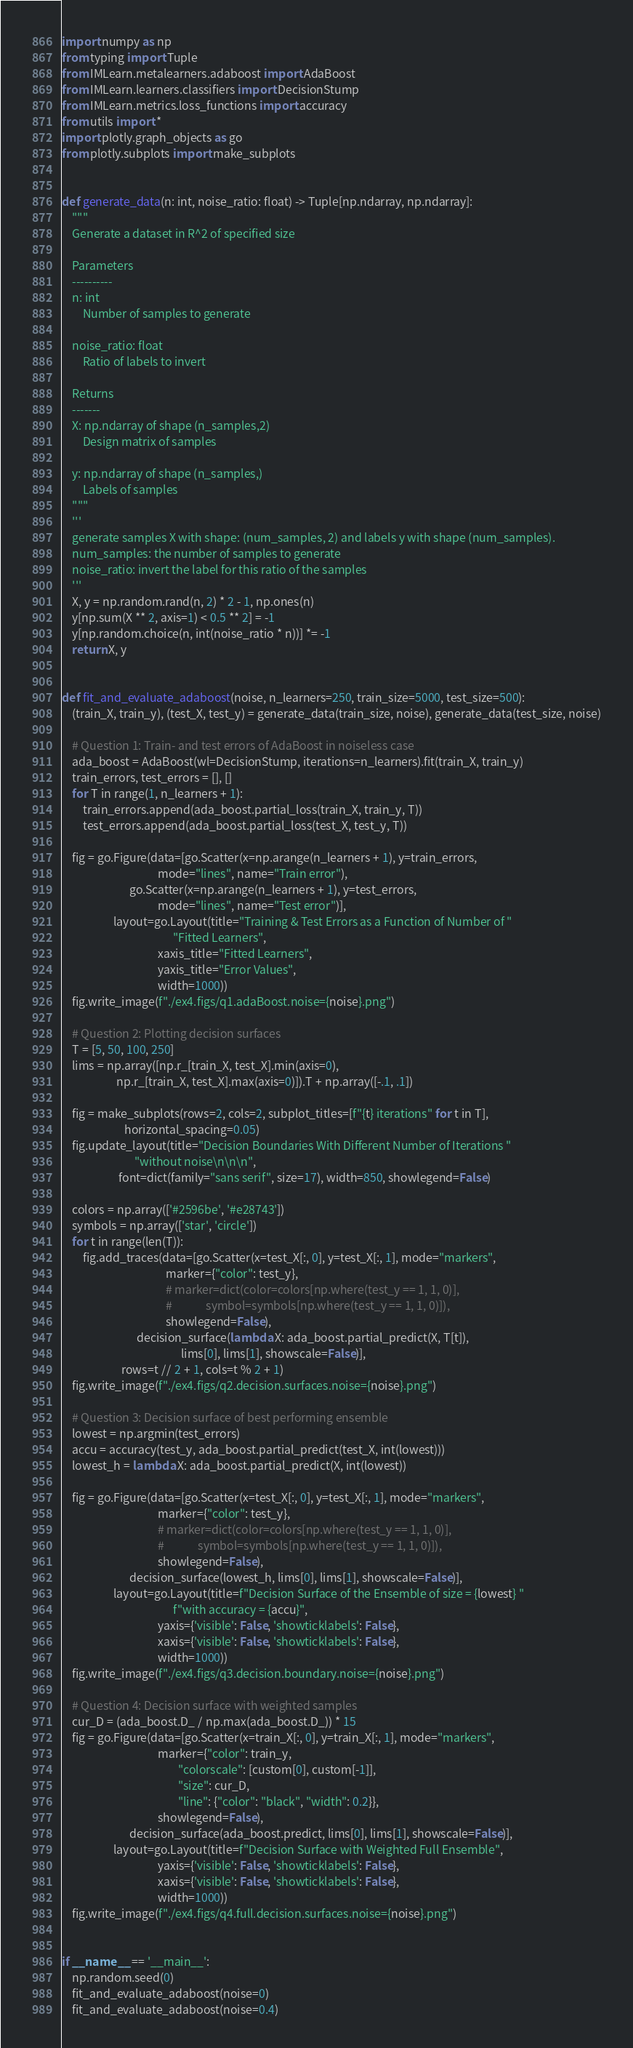<code> <loc_0><loc_0><loc_500><loc_500><_Python_>import numpy as np
from typing import Tuple
from IMLearn.metalearners.adaboost import AdaBoost
from IMLearn.learners.classifiers import DecisionStump
from IMLearn.metrics.loss_functions import accuracy
from utils import *
import plotly.graph_objects as go
from plotly.subplots import make_subplots


def generate_data(n: int, noise_ratio: float) -> Tuple[np.ndarray, np.ndarray]:
    """
    Generate a dataset in R^2 of specified size

    Parameters
    ----------
    n: int
        Number of samples to generate

    noise_ratio: float
        Ratio of labels to invert

    Returns
    -------
    X: np.ndarray of shape (n_samples,2)
        Design matrix of samples

    y: np.ndarray of shape (n_samples,)
        Labels of samples
    """
    '''
    generate samples X with shape: (num_samples, 2) and labels y with shape (num_samples).
    num_samples: the number of samples to generate
    noise_ratio: invert the label for this ratio of the samples
    '''
    X, y = np.random.rand(n, 2) * 2 - 1, np.ones(n)
    y[np.sum(X ** 2, axis=1) < 0.5 ** 2] = -1
    y[np.random.choice(n, int(noise_ratio * n))] *= -1
    return X, y


def fit_and_evaluate_adaboost(noise, n_learners=250, train_size=5000, test_size=500):
    (train_X, train_y), (test_X, test_y) = generate_data(train_size, noise), generate_data(test_size, noise)

    # Question 1: Train- and test errors of AdaBoost in noiseless case
    ada_boost = AdaBoost(wl=DecisionStump, iterations=n_learners).fit(train_X, train_y)
    train_errors, test_errors = [], []
    for T in range(1, n_learners + 1):
        train_errors.append(ada_boost.partial_loss(train_X, train_y, T))
        test_errors.append(ada_boost.partial_loss(test_X, test_y, T))

    fig = go.Figure(data=[go.Scatter(x=np.arange(n_learners + 1), y=train_errors,
                                     mode="lines", name="Train error"),
                          go.Scatter(x=np.arange(n_learners + 1), y=test_errors,
                                     mode="lines", name="Test error")],
                    layout=go.Layout(title="Training & Test Errors as a Function of Number of "
                                           "Fitted Learners",
                                     xaxis_title="Fitted Learners",
                                     yaxis_title="Error Values",
                                     width=1000))
    fig.write_image(f"./ex4.figs/q1.adaBoost.noise={noise}.png")

    # Question 2: Plotting decision surfaces
    T = [5, 50, 100, 250]
    lims = np.array([np.r_[train_X, test_X].min(axis=0),
                     np.r_[train_X, test_X].max(axis=0)]).T + np.array([-.1, .1])

    fig = make_subplots(rows=2, cols=2, subplot_titles=[f"{t} iterations" for t in T],
                        horizontal_spacing=0.05)
    fig.update_layout(title="Decision Boundaries With Different Number of Iterations "
                            "without noise\n\n\n",
                      font=dict(family="sans serif", size=17), width=850, showlegend=False)

    colors = np.array(['#2596be', '#e28743'])
    symbols = np.array(['star', 'circle'])
    for t in range(len(T)):
        fig.add_traces(data=[go.Scatter(x=test_X[:, 0], y=test_X[:, 1], mode="markers",
                                        marker={"color": test_y},
                                        # marker=dict(color=colors[np.where(test_y == 1, 1, 0)],
                                        #             symbol=symbols[np.where(test_y == 1, 1, 0)]),
                                        showlegend=False),
                             decision_surface(lambda X: ada_boost.partial_predict(X, T[t]),
                                              lims[0], lims[1], showscale=False)],
                       rows=t // 2 + 1, cols=t % 2 + 1)
    fig.write_image(f"./ex4.figs/q2.decision.surfaces.noise={noise}.png")

    # Question 3: Decision surface of best performing ensemble
    lowest = np.argmin(test_errors)
    accu = accuracy(test_y, ada_boost.partial_predict(test_X, int(lowest)))
    lowest_h = lambda X: ada_boost.partial_predict(X, int(lowest))

    fig = go.Figure(data=[go.Scatter(x=test_X[:, 0], y=test_X[:, 1], mode="markers",
                                     marker={"color": test_y},
                                     # marker=dict(color=colors[np.where(test_y == 1, 1, 0)],
                                     #             symbol=symbols[np.where(test_y == 1, 1, 0)]),
                                     showlegend=False),
                          decision_surface(lowest_h, lims[0], lims[1], showscale=False)],
                    layout=go.Layout(title=f"Decision Surface of the Ensemble of size = {lowest} "
                                           f"with accuracy = {accu}",
                                     yaxis={'visible': False, 'showticklabels': False},
                                     xaxis={'visible': False, 'showticklabels': False},
                                     width=1000))
    fig.write_image(f"./ex4.figs/q3.decision.boundary.noise={noise}.png")

    # Question 4: Decision surface with weighted samples
    cur_D = (ada_boost.D_ / np.max(ada_boost.D_)) * 15
    fig = go.Figure(data=[go.Scatter(x=train_X[:, 0], y=train_X[:, 1], mode="markers",
                                     marker={"color": train_y,
                                             "colorscale": [custom[0], custom[-1]],
                                             "size": cur_D,
                                             "line": {"color": "black", "width": 0.2}},
                                     showlegend=False),
                          decision_surface(ada_boost.predict, lims[0], lims[1], showscale=False)],
                    layout=go.Layout(title=f"Decision Surface with Weighted Full Ensemble",
                                     yaxis={'visible': False, 'showticklabels': False},
                                     xaxis={'visible': False, 'showticklabels': False},
                                     width=1000))
    fig.write_image(f"./ex4.figs/q4.full.decision.surfaces.noise={noise}.png")


if __name__ == '__main__':
    np.random.seed(0)
    fit_and_evaluate_adaboost(noise=0)
    fit_and_evaluate_adaboost(noise=0.4)
</code> 